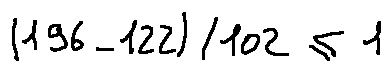Convert formula to latex. <formula><loc_0><loc_0><loc_500><loc_500>( 1 9 6 - 1 2 2 ) / 1 0 2 \leq 1</formula> 